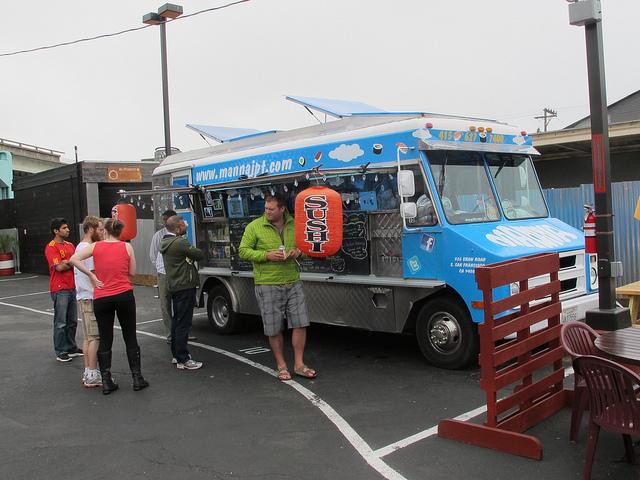How many people are there?
Keep it brief. 6. Are the men in uniform?
Quick response, please. No. How many tires are visible?
Be succinct. 2. What is the best selling product?
Give a very brief answer. Sushi. What is the shirt color of the guy?
Be succinct. Green. Where is the shortest person who is wearing red?
Answer briefly. Left. What type of wire is the man working on?
Keep it brief. None. Is this an American truck?
Keep it brief. Yes. What is the occupation of these men?
Short answer required. Food service. What does this truck serve according to the Japanese lantern?
Short answer required. Sushi. How many food trucks are there?
Be succinct. 1. Is there a statue?
Write a very short answer. No. What is not allowed according to the sign?
Be succinct. Loitering. How many people are in the photo?
Write a very short answer. 6. Is there a horse in a parking lot?
Give a very brief answer. No. What color is the fire truck?
Concise answer only. Blue. What type of vehicle is shown?
Answer briefly. Food truck. Is this van stationary?
Write a very short answer. Yes. What color is the truck?
Short answer required. Blue. Is it cold?
Quick response, please. No. How many people are wearing sandals?
Quick response, please. 1. What is the name on the side of the food truck?
Write a very short answer. Sushi. What sort of outerwear does she have on?
Be succinct. Tank top. Is the man traveling?
Answer briefly. No. How many people are wearing white outside of the truck?
Be succinct. 2. How many men are wearing hats?
Answer briefly. 0. Is this a Mexican truck?
Quick response, please. No. Are these guys wearing hat?
Give a very brief answer. No. How many people are waiting?
Short answer required. 6. What color is the van?
Concise answer only. Blue. What do the hoses carry?
Concise answer only. Water. How apparently popular is food-truck sushi?
Answer briefly. Very. What kind of food does the food truck sell?
Write a very short answer. Sushi. What college does this man support?
Be succinct. None. Was this taken in a rural setting?
Give a very brief answer. No. Is the lady holding eggs?
Keep it brief. No. Are they all wearing jeans?
Concise answer only. No. 